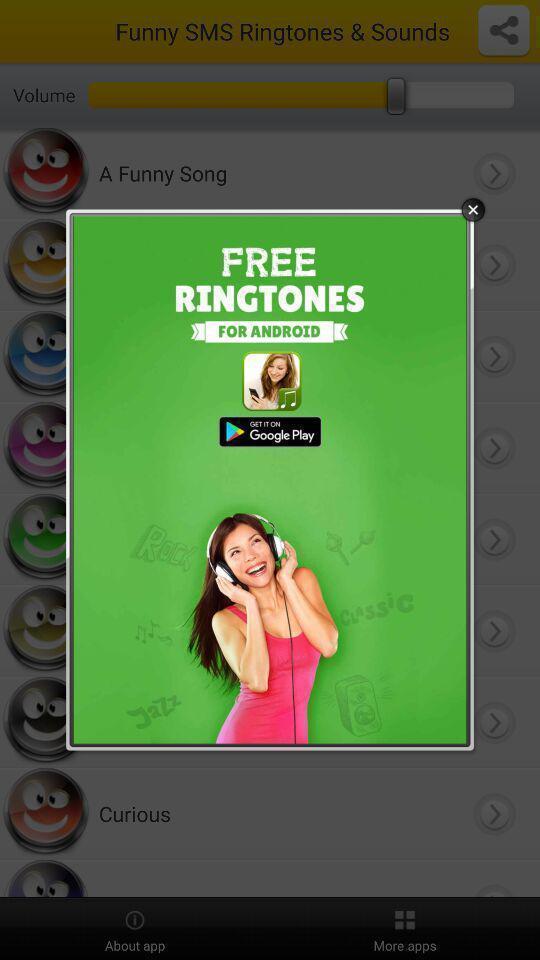Describe the content in this image. Pop-up shows an alert message. 